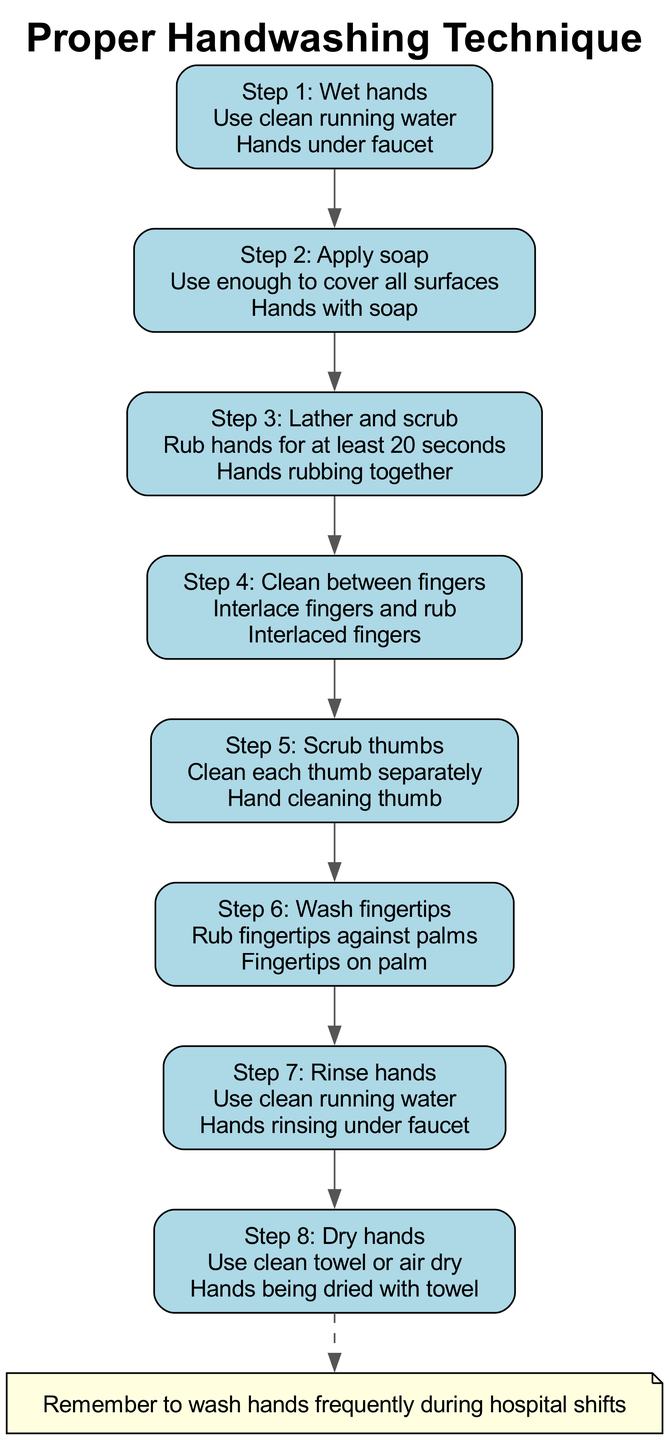What is the first step in the handwashing process? The first step is represented by the first node in the diagram, which indicates that one should "Wet hands" using clean running water. This information is clearly stated at the top of the flow.
Answer: Wet hands How many steps are there in total? By counting the nodes in the diagram, we can see that there are eight steps listed from "Wet hands" to "Dry hands." Each step represents a distinct part of the handwashing process.
Answer: Eight What step comes after applying soap? To determine the step following "Apply soap," we can follow the arrows from the "Apply soap" node. The next node leads to "Lather and scrub," indicating this is the subsequent action.
Answer: Lather and scrub What should be done while washing fingertips? In this step, the description states to "Rub fingertips against palms." This is specifically what individuals are instructed to do when they reach this point in the handwashing process.
Answer: Rub fingertips against palms What is the last step depicted in the diagram? The last node in the sequence leads to "Dry hands," which indicates it is the final step in the handwashing process. This concludes the procedure outlined in the diagram.
Answer: Dry hands Which step emphasizes cleaning between fingers? The node directly addressing this is labeled "Clean between fingers," which describes the action of interlacing fingers and rubbing, highlighting its importance within the handwashing technique.
Answer: Clean between fingers What is noted at the bottom of the diagram? The note at the bottom states, "Remember to wash hands frequently during hospital shifts," providing an essential reminder for healthcare professionals regarding the importance of hand hygiene.
Answer: Remember to wash hands frequently during hospital shifts How long should you lather and scrub hands according to the diagram? The description in the "Lather and scrub" node specifies "for at least 20 seconds," providing a clear guideline for the duration of the scrubbing action during handwashing.
Answer: At least 20 seconds 